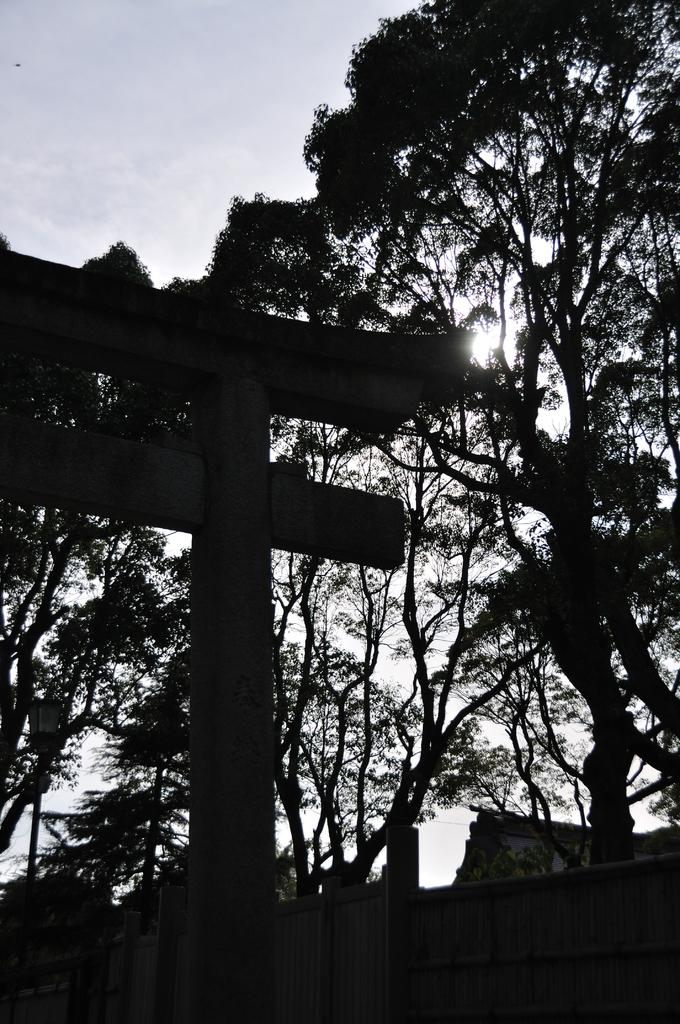What can be seen attached to a pole in the image? There is a street sign attached to a pole in the image. What else is visible in the image besides the street sign? There is a gate and a group of trees visible in the image. What is the condition of the sky in the image? The sky appears to be cloudy in the image. Can you describe the color of the sky? The color of the sky cannot be determined from the provided facts. What flavor of health supplement can be seen in the image? There is no health supplement or flavor mentioned in the image. Is there a comb visible in the image? There is no comb present in the image. 